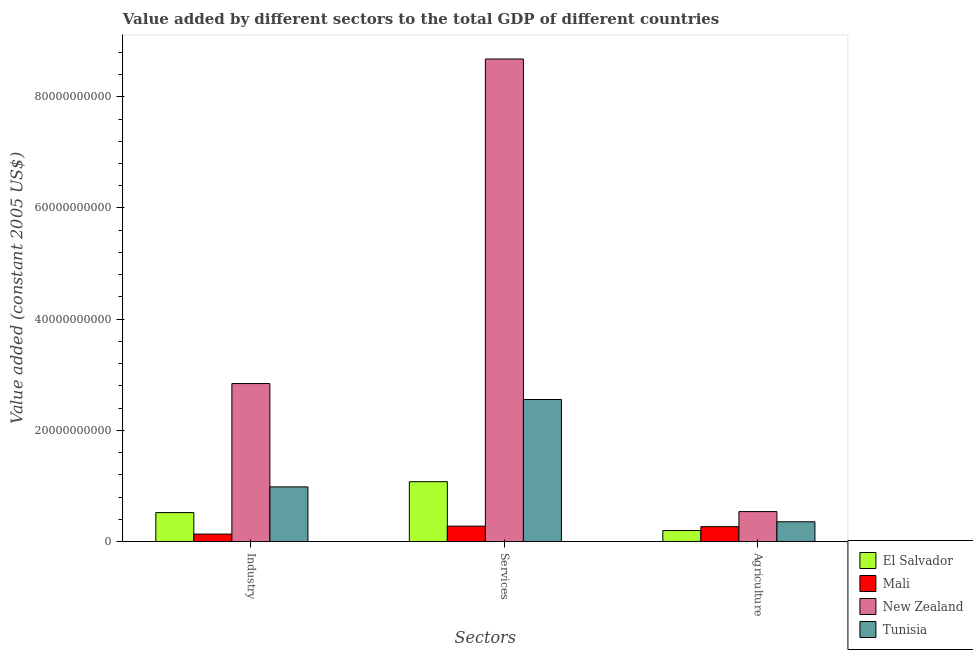How many different coloured bars are there?
Offer a terse response. 4. How many groups of bars are there?
Your answer should be very brief. 3. Are the number of bars per tick equal to the number of legend labels?
Keep it short and to the point. Yes. How many bars are there on the 1st tick from the left?
Your response must be concise. 4. How many bars are there on the 3rd tick from the right?
Make the answer very short. 4. What is the label of the 1st group of bars from the left?
Your response must be concise. Industry. What is the value added by industrial sector in Mali?
Give a very brief answer. 1.35e+09. Across all countries, what is the maximum value added by agricultural sector?
Provide a short and direct response. 5.39e+09. Across all countries, what is the minimum value added by industrial sector?
Ensure brevity in your answer.  1.35e+09. In which country was the value added by services maximum?
Keep it short and to the point. New Zealand. In which country was the value added by agricultural sector minimum?
Offer a very short reply. El Salvador. What is the total value added by industrial sector in the graph?
Make the answer very short. 4.48e+1. What is the difference between the value added by agricultural sector in Tunisia and that in El Salvador?
Your answer should be very brief. 1.57e+09. What is the difference between the value added by services in New Zealand and the value added by industrial sector in Mali?
Keep it short and to the point. 8.54e+1. What is the average value added by agricultural sector per country?
Offer a terse response. 3.41e+09. What is the difference between the value added by industrial sector and value added by services in El Salvador?
Offer a terse response. -5.55e+09. What is the ratio of the value added by industrial sector in New Zealand to that in El Salvador?
Give a very brief answer. 5.45. Is the value added by services in El Salvador less than that in Tunisia?
Make the answer very short. Yes. Is the difference between the value added by services in Mali and Tunisia greater than the difference between the value added by industrial sector in Mali and Tunisia?
Offer a terse response. No. What is the difference between the highest and the second highest value added by industrial sector?
Make the answer very short. 1.86e+1. What is the difference between the highest and the lowest value added by agricultural sector?
Provide a succinct answer. 3.40e+09. In how many countries, is the value added by industrial sector greater than the average value added by industrial sector taken over all countries?
Provide a short and direct response. 1. Is the sum of the value added by agricultural sector in New Zealand and Tunisia greater than the maximum value added by industrial sector across all countries?
Offer a terse response. No. What does the 2nd bar from the left in Services represents?
Provide a succinct answer. Mali. What does the 1st bar from the right in Industry represents?
Make the answer very short. Tunisia. Are all the bars in the graph horizontal?
Your answer should be very brief. No. Are the values on the major ticks of Y-axis written in scientific E-notation?
Your answer should be very brief. No. How many legend labels are there?
Your answer should be compact. 4. How are the legend labels stacked?
Your response must be concise. Vertical. What is the title of the graph?
Provide a succinct answer. Value added by different sectors to the total GDP of different countries. Does "Yemen, Rep." appear as one of the legend labels in the graph?
Your answer should be very brief. No. What is the label or title of the X-axis?
Offer a very short reply. Sectors. What is the label or title of the Y-axis?
Make the answer very short. Value added (constant 2005 US$). What is the Value added (constant 2005 US$) in El Salvador in Industry?
Give a very brief answer. 5.21e+09. What is the Value added (constant 2005 US$) in Mali in Industry?
Offer a very short reply. 1.35e+09. What is the Value added (constant 2005 US$) in New Zealand in Industry?
Ensure brevity in your answer.  2.84e+1. What is the Value added (constant 2005 US$) of Tunisia in Industry?
Provide a short and direct response. 9.84e+09. What is the Value added (constant 2005 US$) of El Salvador in Services?
Provide a short and direct response. 1.08e+1. What is the Value added (constant 2005 US$) of Mali in Services?
Provide a succinct answer. 2.77e+09. What is the Value added (constant 2005 US$) in New Zealand in Services?
Give a very brief answer. 8.68e+1. What is the Value added (constant 2005 US$) in Tunisia in Services?
Make the answer very short. 2.55e+1. What is the Value added (constant 2005 US$) in El Salvador in Agriculture?
Your answer should be very brief. 1.99e+09. What is the Value added (constant 2005 US$) of Mali in Agriculture?
Give a very brief answer. 2.69e+09. What is the Value added (constant 2005 US$) of New Zealand in Agriculture?
Offer a terse response. 5.39e+09. What is the Value added (constant 2005 US$) of Tunisia in Agriculture?
Ensure brevity in your answer.  3.56e+09. Across all Sectors, what is the maximum Value added (constant 2005 US$) in El Salvador?
Make the answer very short. 1.08e+1. Across all Sectors, what is the maximum Value added (constant 2005 US$) in Mali?
Your response must be concise. 2.77e+09. Across all Sectors, what is the maximum Value added (constant 2005 US$) of New Zealand?
Keep it short and to the point. 8.68e+1. Across all Sectors, what is the maximum Value added (constant 2005 US$) of Tunisia?
Make the answer very short. 2.55e+1. Across all Sectors, what is the minimum Value added (constant 2005 US$) of El Salvador?
Provide a succinct answer. 1.99e+09. Across all Sectors, what is the minimum Value added (constant 2005 US$) of Mali?
Ensure brevity in your answer.  1.35e+09. Across all Sectors, what is the minimum Value added (constant 2005 US$) in New Zealand?
Make the answer very short. 5.39e+09. Across all Sectors, what is the minimum Value added (constant 2005 US$) of Tunisia?
Your response must be concise. 3.56e+09. What is the total Value added (constant 2005 US$) of El Salvador in the graph?
Give a very brief answer. 1.80e+1. What is the total Value added (constant 2005 US$) of Mali in the graph?
Offer a very short reply. 6.80e+09. What is the total Value added (constant 2005 US$) in New Zealand in the graph?
Make the answer very short. 1.21e+11. What is the total Value added (constant 2005 US$) of Tunisia in the graph?
Your answer should be compact. 3.89e+1. What is the difference between the Value added (constant 2005 US$) of El Salvador in Industry and that in Services?
Give a very brief answer. -5.55e+09. What is the difference between the Value added (constant 2005 US$) in Mali in Industry and that in Services?
Your response must be concise. -1.42e+09. What is the difference between the Value added (constant 2005 US$) of New Zealand in Industry and that in Services?
Your answer should be very brief. -5.84e+1. What is the difference between the Value added (constant 2005 US$) in Tunisia in Industry and that in Services?
Offer a very short reply. -1.57e+1. What is the difference between the Value added (constant 2005 US$) of El Salvador in Industry and that in Agriculture?
Offer a terse response. 3.22e+09. What is the difference between the Value added (constant 2005 US$) of Mali in Industry and that in Agriculture?
Your answer should be compact. -1.34e+09. What is the difference between the Value added (constant 2005 US$) in New Zealand in Industry and that in Agriculture?
Offer a terse response. 2.30e+1. What is the difference between the Value added (constant 2005 US$) of Tunisia in Industry and that in Agriculture?
Offer a very short reply. 6.28e+09. What is the difference between the Value added (constant 2005 US$) of El Salvador in Services and that in Agriculture?
Provide a succinct answer. 8.78e+09. What is the difference between the Value added (constant 2005 US$) of Mali in Services and that in Agriculture?
Provide a short and direct response. 8.58e+07. What is the difference between the Value added (constant 2005 US$) in New Zealand in Services and that in Agriculture?
Keep it short and to the point. 8.14e+1. What is the difference between the Value added (constant 2005 US$) in Tunisia in Services and that in Agriculture?
Keep it short and to the point. 2.20e+1. What is the difference between the Value added (constant 2005 US$) in El Salvador in Industry and the Value added (constant 2005 US$) in Mali in Services?
Provide a succinct answer. 2.44e+09. What is the difference between the Value added (constant 2005 US$) of El Salvador in Industry and the Value added (constant 2005 US$) of New Zealand in Services?
Ensure brevity in your answer.  -8.16e+1. What is the difference between the Value added (constant 2005 US$) in El Salvador in Industry and the Value added (constant 2005 US$) in Tunisia in Services?
Keep it short and to the point. -2.03e+1. What is the difference between the Value added (constant 2005 US$) in Mali in Industry and the Value added (constant 2005 US$) in New Zealand in Services?
Offer a terse response. -8.54e+1. What is the difference between the Value added (constant 2005 US$) of Mali in Industry and the Value added (constant 2005 US$) of Tunisia in Services?
Provide a short and direct response. -2.42e+1. What is the difference between the Value added (constant 2005 US$) of New Zealand in Industry and the Value added (constant 2005 US$) of Tunisia in Services?
Keep it short and to the point. 2.87e+09. What is the difference between the Value added (constant 2005 US$) of El Salvador in Industry and the Value added (constant 2005 US$) of Mali in Agriculture?
Your answer should be compact. 2.53e+09. What is the difference between the Value added (constant 2005 US$) of El Salvador in Industry and the Value added (constant 2005 US$) of New Zealand in Agriculture?
Provide a succinct answer. -1.79e+08. What is the difference between the Value added (constant 2005 US$) in El Salvador in Industry and the Value added (constant 2005 US$) in Tunisia in Agriculture?
Your answer should be very brief. 1.65e+09. What is the difference between the Value added (constant 2005 US$) in Mali in Industry and the Value added (constant 2005 US$) in New Zealand in Agriculture?
Your answer should be very brief. -4.04e+09. What is the difference between the Value added (constant 2005 US$) in Mali in Industry and the Value added (constant 2005 US$) in Tunisia in Agriculture?
Provide a succinct answer. -2.21e+09. What is the difference between the Value added (constant 2005 US$) of New Zealand in Industry and the Value added (constant 2005 US$) of Tunisia in Agriculture?
Keep it short and to the point. 2.49e+1. What is the difference between the Value added (constant 2005 US$) of El Salvador in Services and the Value added (constant 2005 US$) of Mali in Agriculture?
Offer a very short reply. 8.08e+09. What is the difference between the Value added (constant 2005 US$) of El Salvador in Services and the Value added (constant 2005 US$) of New Zealand in Agriculture?
Provide a succinct answer. 5.38e+09. What is the difference between the Value added (constant 2005 US$) of El Salvador in Services and the Value added (constant 2005 US$) of Tunisia in Agriculture?
Your response must be concise. 7.21e+09. What is the difference between the Value added (constant 2005 US$) in Mali in Services and the Value added (constant 2005 US$) in New Zealand in Agriculture?
Your answer should be very brief. -2.62e+09. What is the difference between the Value added (constant 2005 US$) of Mali in Services and the Value added (constant 2005 US$) of Tunisia in Agriculture?
Provide a short and direct response. -7.89e+08. What is the difference between the Value added (constant 2005 US$) in New Zealand in Services and the Value added (constant 2005 US$) in Tunisia in Agriculture?
Provide a short and direct response. 8.32e+1. What is the average Value added (constant 2005 US$) in El Salvador per Sectors?
Your answer should be very brief. 5.99e+09. What is the average Value added (constant 2005 US$) of Mali per Sectors?
Make the answer very short. 2.27e+09. What is the average Value added (constant 2005 US$) of New Zealand per Sectors?
Keep it short and to the point. 4.02e+1. What is the average Value added (constant 2005 US$) in Tunisia per Sectors?
Make the answer very short. 1.30e+1. What is the difference between the Value added (constant 2005 US$) of El Salvador and Value added (constant 2005 US$) of Mali in Industry?
Your answer should be compact. 3.87e+09. What is the difference between the Value added (constant 2005 US$) of El Salvador and Value added (constant 2005 US$) of New Zealand in Industry?
Your answer should be compact. -2.32e+1. What is the difference between the Value added (constant 2005 US$) in El Salvador and Value added (constant 2005 US$) in Tunisia in Industry?
Offer a terse response. -4.62e+09. What is the difference between the Value added (constant 2005 US$) in Mali and Value added (constant 2005 US$) in New Zealand in Industry?
Provide a short and direct response. -2.71e+1. What is the difference between the Value added (constant 2005 US$) of Mali and Value added (constant 2005 US$) of Tunisia in Industry?
Your answer should be compact. -8.49e+09. What is the difference between the Value added (constant 2005 US$) of New Zealand and Value added (constant 2005 US$) of Tunisia in Industry?
Offer a terse response. 1.86e+1. What is the difference between the Value added (constant 2005 US$) in El Salvador and Value added (constant 2005 US$) in Mali in Services?
Your answer should be very brief. 8.00e+09. What is the difference between the Value added (constant 2005 US$) in El Salvador and Value added (constant 2005 US$) in New Zealand in Services?
Offer a very short reply. -7.60e+1. What is the difference between the Value added (constant 2005 US$) of El Salvador and Value added (constant 2005 US$) of Tunisia in Services?
Provide a succinct answer. -1.48e+1. What is the difference between the Value added (constant 2005 US$) in Mali and Value added (constant 2005 US$) in New Zealand in Services?
Ensure brevity in your answer.  -8.40e+1. What is the difference between the Value added (constant 2005 US$) of Mali and Value added (constant 2005 US$) of Tunisia in Services?
Offer a terse response. -2.28e+1. What is the difference between the Value added (constant 2005 US$) of New Zealand and Value added (constant 2005 US$) of Tunisia in Services?
Make the answer very short. 6.12e+1. What is the difference between the Value added (constant 2005 US$) in El Salvador and Value added (constant 2005 US$) in Mali in Agriculture?
Provide a short and direct response. -6.93e+08. What is the difference between the Value added (constant 2005 US$) in El Salvador and Value added (constant 2005 US$) in New Zealand in Agriculture?
Your answer should be compact. -3.40e+09. What is the difference between the Value added (constant 2005 US$) of El Salvador and Value added (constant 2005 US$) of Tunisia in Agriculture?
Your answer should be very brief. -1.57e+09. What is the difference between the Value added (constant 2005 US$) in Mali and Value added (constant 2005 US$) in New Zealand in Agriculture?
Provide a short and direct response. -2.71e+09. What is the difference between the Value added (constant 2005 US$) of Mali and Value added (constant 2005 US$) of Tunisia in Agriculture?
Keep it short and to the point. -8.75e+08. What is the difference between the Value added (constant 2005 US$) in New Zealand and Value added (constant 2005 US$) in Tunisia in Agriculture?
Keep it short and to the point. 1.83e+09. What is the ratio of the Value added (constant 2005 US$) of El Salvador in Industry to that in Services?
Give a very brief answer. 0.48. What is the ratio of the Value added (constant 2005 US$) of Mali in Industry to that in Services?
Provide a succinct answer. 0.49. What is the ratio of the Value added (constant 2005 US$) in New Zealand in Industry to that in Services?
Your response must be concise. 0.33. What is the ratio of the Value added (constant 2005 US$) in Tunisia in Industry to that in Services?
Ensure brevity in your answer.  0.39. What is the ratio of the Value added (constant 2005 US$) in El Salvador in Industry to that in Agriculture?
Your response must be concise. 2.62. What is the ratio of the Value added (constant 2005 US$) in Mali in Industry to that in Agriculture?
Your response must be concise. 0.5. What is the ratio of the Value added (constant 2005 US$) of New Zealand in Industry to that in Agriculture?
Your response must be concise. 5.27. What is the ratio of the Value added (constant 2005 US$) of Tunisia in Industry to that in Agriculture?
Keep it short and to the point. 2.76. What is the ratio of the Value added (constant 2005 US$) of El Salvador in Services to that in Agriculture?
Give a very brief answer. 5.4. What is the ratio of the Value added (constant 2005 US$) in Mali in Services to that in Agriculture?
Keep it short and to the point. 1.03. What is the ratio of the Value added (constant 2005 US$) of New Zealand in Services to that in Agriculture?
Offer a very short reply. 16.1. What is the ratio of the Value added (constant 2005 US$) in Tunisia in Services to that in Agriculture?
Offer a very short reply. 7.18. What is the difference between the highest and the second highest Value added (constant 2005 US$) of El Salvador?
Provide a succinct answer. 5.55e+09. What is the difference between the highest and the second highest Value added (constant 2005 US$) in Mali?
Provide a short and direct response. 8.58e+07. What is the difference between the highest and the second highest Value added (constant 2005 US$) in New Zealand?
Provide a succinct answer. 5.84e+1. What is the difference between the highest and the second highest Value added (constant 2005 US$) in Tunisia?
Provide a succinct answer. 1.57e+1. What is the difference between the highest and the lowest Value added (constant 2005 US$) of El Salvador?
Offer a very short reply. 8.78e+09. What is the difference between the highest and the lowest Value added (constant 2005 US$) of Mali?
Keep it short and to the point. 1.42e+09. What is the difference between the highest and the lowest Value added (constant 2005 US$) of New Zealand?
Make the answer very short. 8.14e+1. What is the difference between the highest and the lowest Value added (constant 2005 US$) in Tunisia?
Your answer should be very brief. 2.20e+1. 